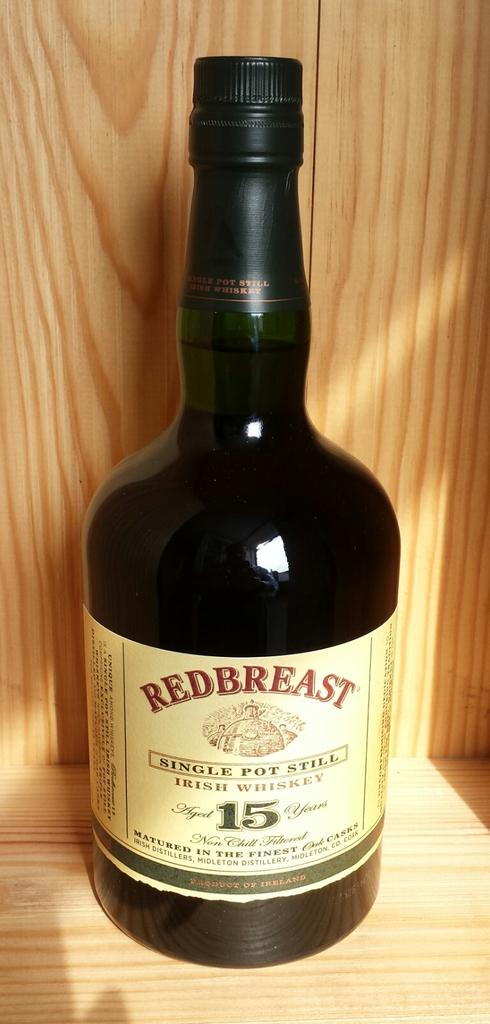<image>
Describe the image concisely. A bottle of Redbreast Irish whiskey on a wooden shelf. 